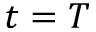Convert formula to latex. <formula><loc_0><loc_0><loc_500><loc_500>t = T</formula> 